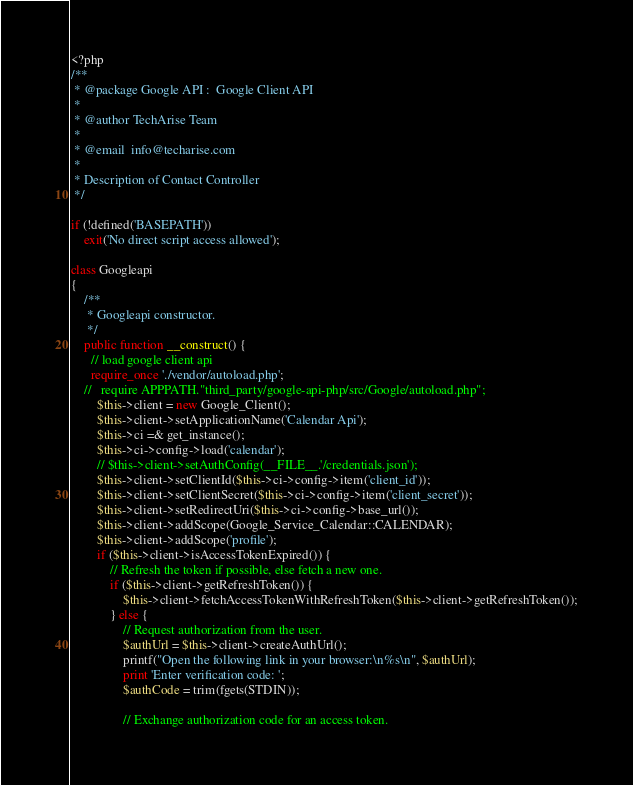Convert code to text. <code><loc_0><loc_0><loc_500><loc_500><_PHP_><?php
/**
 * @package Google API :  Google Client API
 *
 * @author TechArise Team
 *
 * @email  info@techarise.com
 *   
 * Description of Contact Controller
 */

if (!defined('BASEPATH'))
    exit('No direct script access allowed');

class Googleapi 
{
    /**
     * Googleapi constructor.
     */
    public function __construct() {        
      // load google client api 
      require_once './vendor/autoload.php';
    //   require APPPATH."third_party/google-api-php/src/Google/autoload.php";
        $this->client = new Google_Client();
        $this->client->setApplicationName('Calendar Api');
        $this->ci =& get_instance();
        $this->ci->config->load('calendar');
        // $this->client->setAuthConfig(__FILE__.'/credentials.json');
        $this->client->setClientId($this->ci->config->item('client_id'));
        $this->client->setClientSecret($this->ci->config->item('client_secret'));
        $this->client->setRedirectUri($this->ci->config->base_url());
        $this->client->addScope(Google_Service_Calendar::CALENDAR);
        $this->client->addScope('profile');
        if ($this->client->isAccessTokenExpired()) {
            // Refresh the token if possible, else fetch a new one.
            if ($this->client->getRefreshToken()) {
                $this->client->fetchAccessTokenWithRefreshToken($this->client->getRefreshToken());
            } else {
                // Request authorization from the user.
                $authUrl = $this->client->createAuthUrl();
                printf("Open the following link in your browser:\n%s\n", $authUrl);
                print 'Enter verification code: ';
                $authCode = trim(fgets(STDIN));
    
                // Exchange authorization code for an access token.</code> 